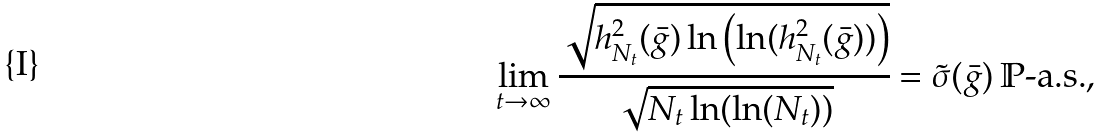<formula> <loc_0><loc_0><loc_500><loc_500>\lim _ { t \to \infty } \cfrac { \sqrt { h _ { N _ { t } } ^ { 2 } ( \bar { g } ) \ln \left ( \ln ( h _ { N _ { t } } ^ { 2 } ( \bar { g } ) ) \right ) } } { \sqrt { N _ { t } \ln ( \ln ( N _ { t } ) ) } } = \tilde { \sigma } ( \bar { g } ) \, \mathbb { P } \text {-a.s.} ,</formula> 